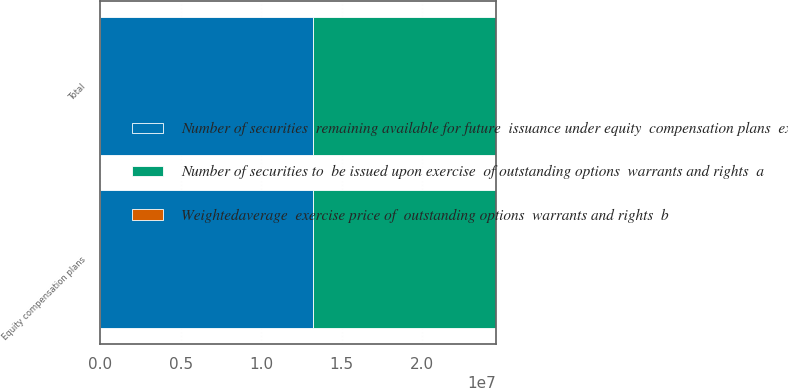Convert chart to OTSL. <chart><loc_0><loc_0><loc_500><loc_500><stacked_bar_chart><ecel><fcel>Equity compensation plans<fcel>Total<nl><fcel>Number of securities  remaining available for future  issuance under equity  compensation plans  excluding  securities reflected in column  a  c<fcel>1.32146e+07<fcel>1.32146e+07<nl><fcel>Weightedaverage  exercise price of  outstanding options  warrants and rights  b<fcel>19.73<fcel>19.73<nl><fcel>Number of securities to  be issued upon exercise  of outstanding options  warrants and rights  a<fcel>1.13844e+07<fcel>1.13844e+07<nl></chart> 